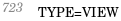Convert code to text. <code><loc_0><loc_0><loc_500><loc_500><_VisualBasic_>TYPE=VIEW</code> 